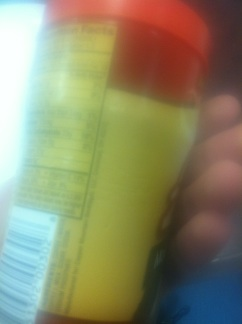Is there anything on the image that might indicate what product this is or its use? Although the details are not very clear, the shape and style suggest it might be a container, possibly for a food or beverage product. The label with what looks to be nutritional facts supports this guess, though no specific product name or usage instructions can be discerned from this image. 